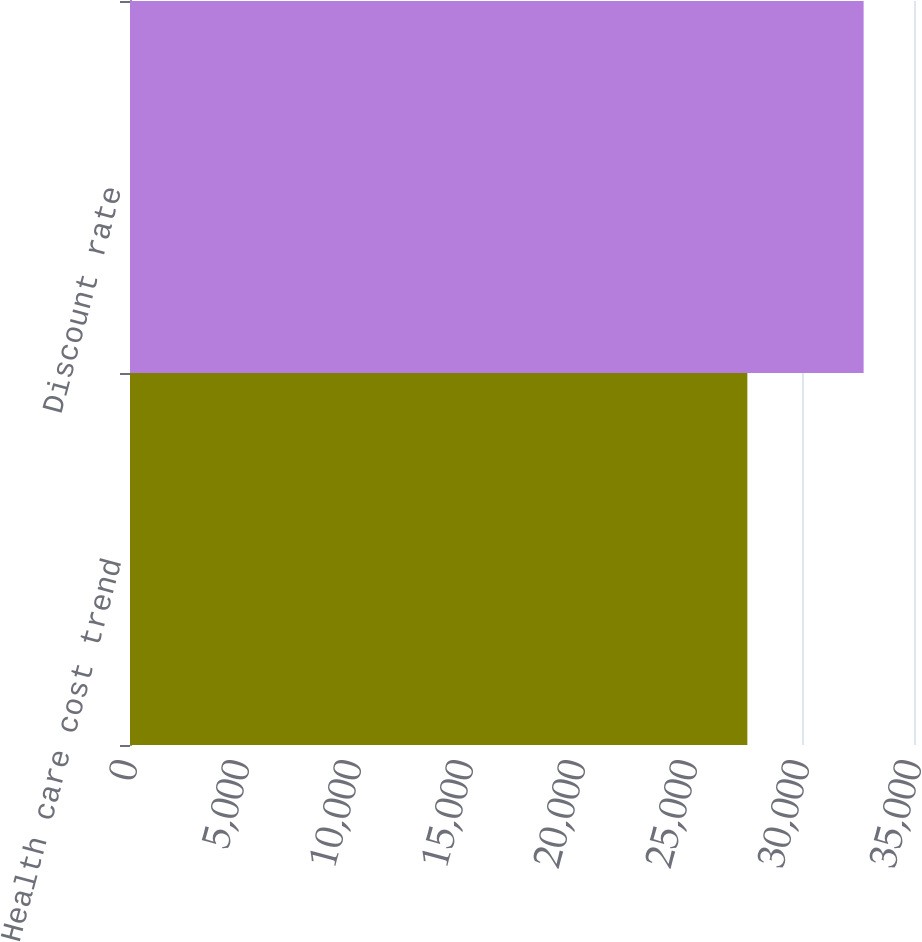<chart> <loc_0><loc_0><loc_500><loc_500><bar_chart><fcel>Health care cost trend<fcel>Discount rate<nl><fcel>27561<fcel>32751<nl></chart> 